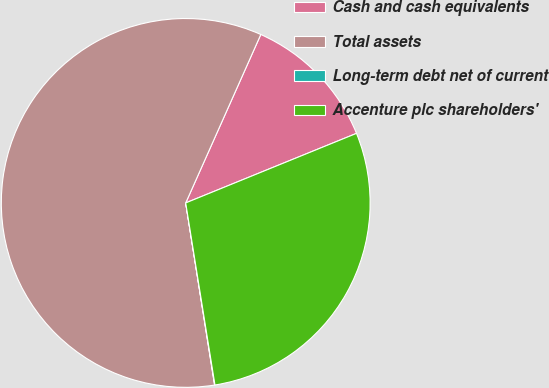<chart> <loc_0><loc_0><loc_500><loc_500><pie_chart><fcel>Cash and cash equivalents<fcel>Total assets<fcel>Long-term debt net of current<fcel>Accenture plc shareholders'<nl><fcel>12.17%<fcel>59.18%<fcel>0.03%<fcel>28.62%<nl></chart> 